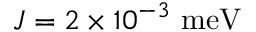<formula> <loc_0><loc_0><loc_500><loc_500>J = 2 \times 1 0 ^ { - 3 } m e V</formula> 